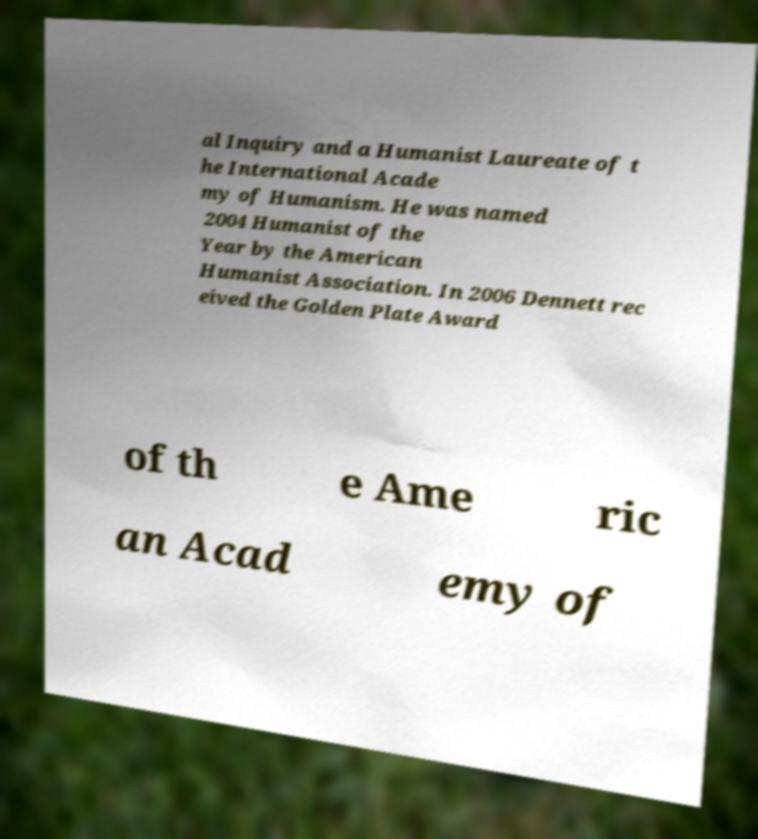Please read and relay the text visible in this image. What does it say? al Inquiry and a Humanist Laureate of t he International Acade my of Humanism. He was named 2004 Humanist of the Year by the American Humanist Association. In 2006 Dennett rec eived the Golden Plate Award of th e Ame ric an Acad emy of 